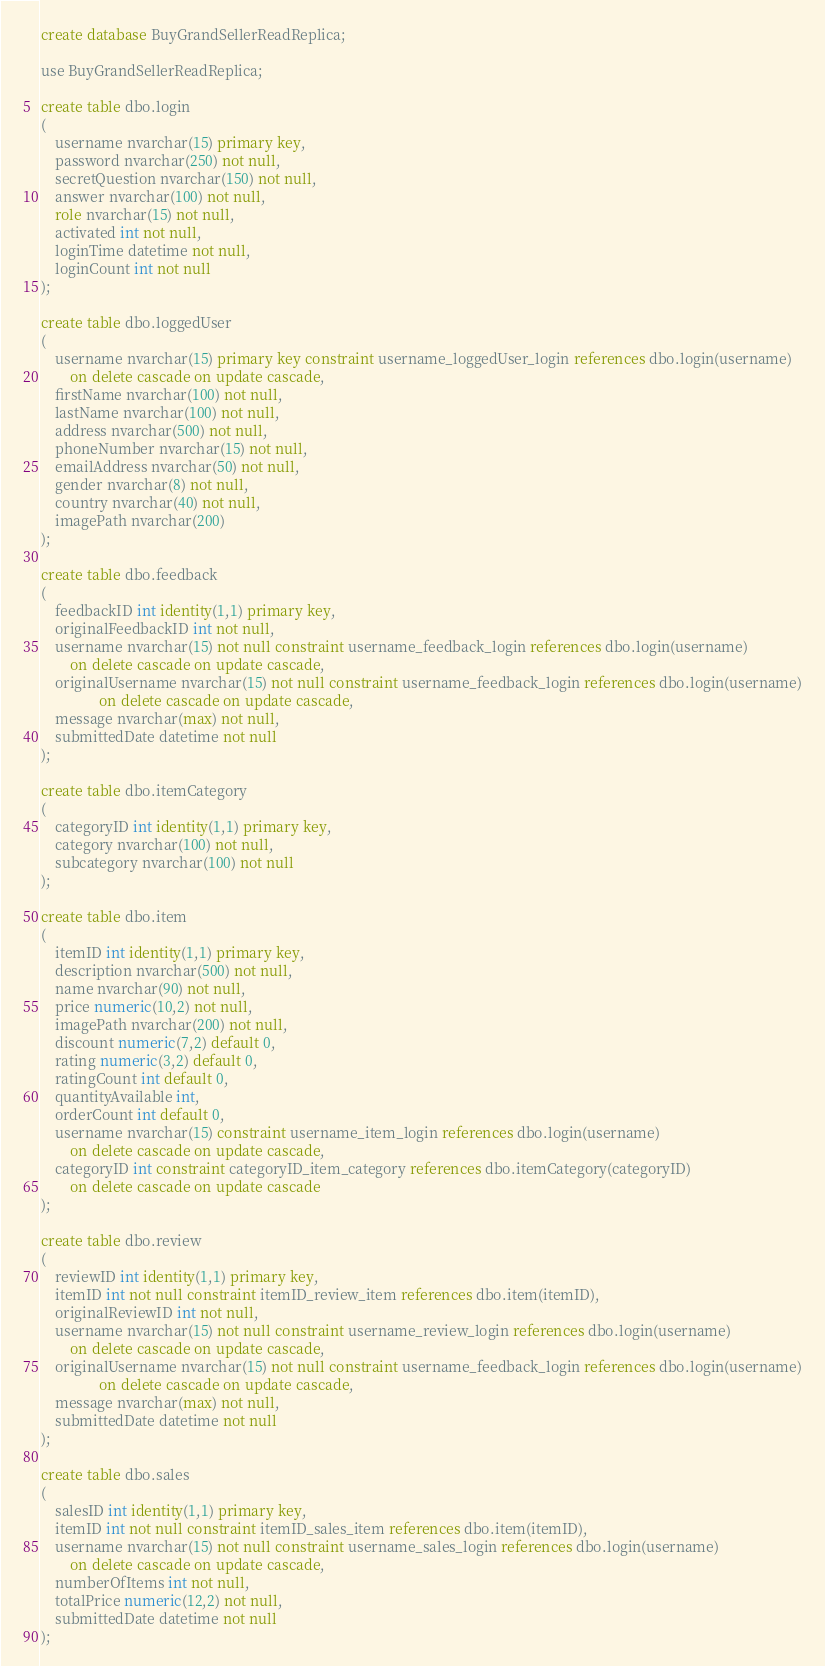Convert code to text. <code><loc_0><loc_0><loc_500><loc_500><_SQL_>create database BuyGrandSellerReadReplica;

use BuyGrandSellerReadReplica;

create table dbo.login
(
	username nvarchar(15) primary key,
	password nvarchar(250) not null,
	secretQuestion nvarchar(150) not null,
	answer nvarchar(100) not null,
	role nvarchar(15) not null,
	activated int not null,
	loginTime datetime not null,
	loginCount int not null
);

create table dbo.loggedUser
(
	username nvarchar(15) primary key constraint username_loggedUser_login references dbo.login(username)
		on delete cascade on update cascade,
	firstName nvarchar(100) not null,
	lastName nvarchar(100) not null,
	address nvarchar(500) not null,
	phoneNumber nvarchar(15) not null,
	emailAddress nvarchar(50) not null,
	gender nvarchar(8) not null,
	country nvarchar(40) not null,
	imagePath nvarchar(200)
);

create table dbo.feedback
(
	feedbackID int identity(1,1) primary key,
	originalFeedbackID int not null,
	username nvarchar(15) not null constraint username_feedback_login references dbo.login(username)
		on delete cascade on update cascade,
	originalUsername nvarchar(15) not null constraint username_feedback_login references dbo.login(username)
				on delete cascade on update cascade,
	message nvarchar(max) not null,
	submittedDate datetime not null
);

create table dbo.itemCategory
(
	categoryID int identity(1,1) primary key,
	category nvarchar(100) not null,
	subcategory nvarchar(100) not null
);

create table dbo.item
(
	itemID int identity(1,1) primary key,
	description nvarchar(500) not null,
	name nvarchar(90) not null,
	price numeric(10,2) not null,
	imagePath nvarchar(200) not null,
	discount numeric(7,2) default 0,
	rating numeric(3,2) default 0,
	ratingCount int default 0,
	quantityAvailable int,
	orderCount int default 0,
	username nvarchar(15) constraint username_item_login references dbo.login(username)
		on delete cascade on update cascade,
	categoryID int constraint categoryID_item_category references dbo.itemCategory(categoryID)
		on delete cascade on update cascade
);

create table dbo.review
(
	reviewID int identity(1,1) primary key,
	itemID int not null constraint itemID_review_item references dbo.item(itemID),
	originalReviewID int not null,
	username nvarchar(15) not null constraint username_review_login references dbo.login(username)
		on delete cascade on update cascade,
	originalUsername nvarchar(15) not null constraint username_feedback_login references dbo.login(username)
				on delete cascade on update cascade,
	message nvarchar(max) not null,
	submittedDate datetime not null
);

create table dbo.sales
(
	salesID int identity(1,1) primary key,
	itemID int not null constraint itemID_sales_item references dbo.item(itemID),
	username nvarchar(15) not null constraint username_sales_login references dbo.login(username)
		on delete cascade on update cascade,
	numberOfItems int not null,
	totalPrice numeric(12,2) not null,
	submittedDate datetime not null
);
</code> 